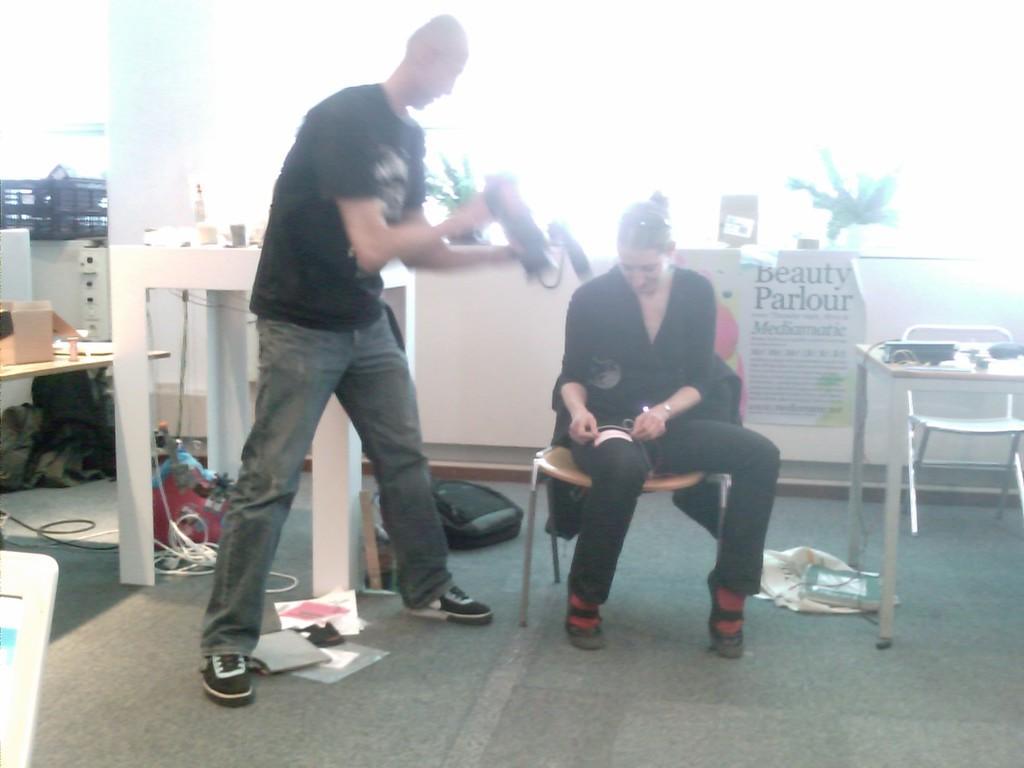How would you summarize this image in a sentence or two? A person is standing holding something. A lady is sitting on chair. On the floor there are bag, papers , wires. There is a table and a chair. In the background there is a notice. There is a box on the table. 